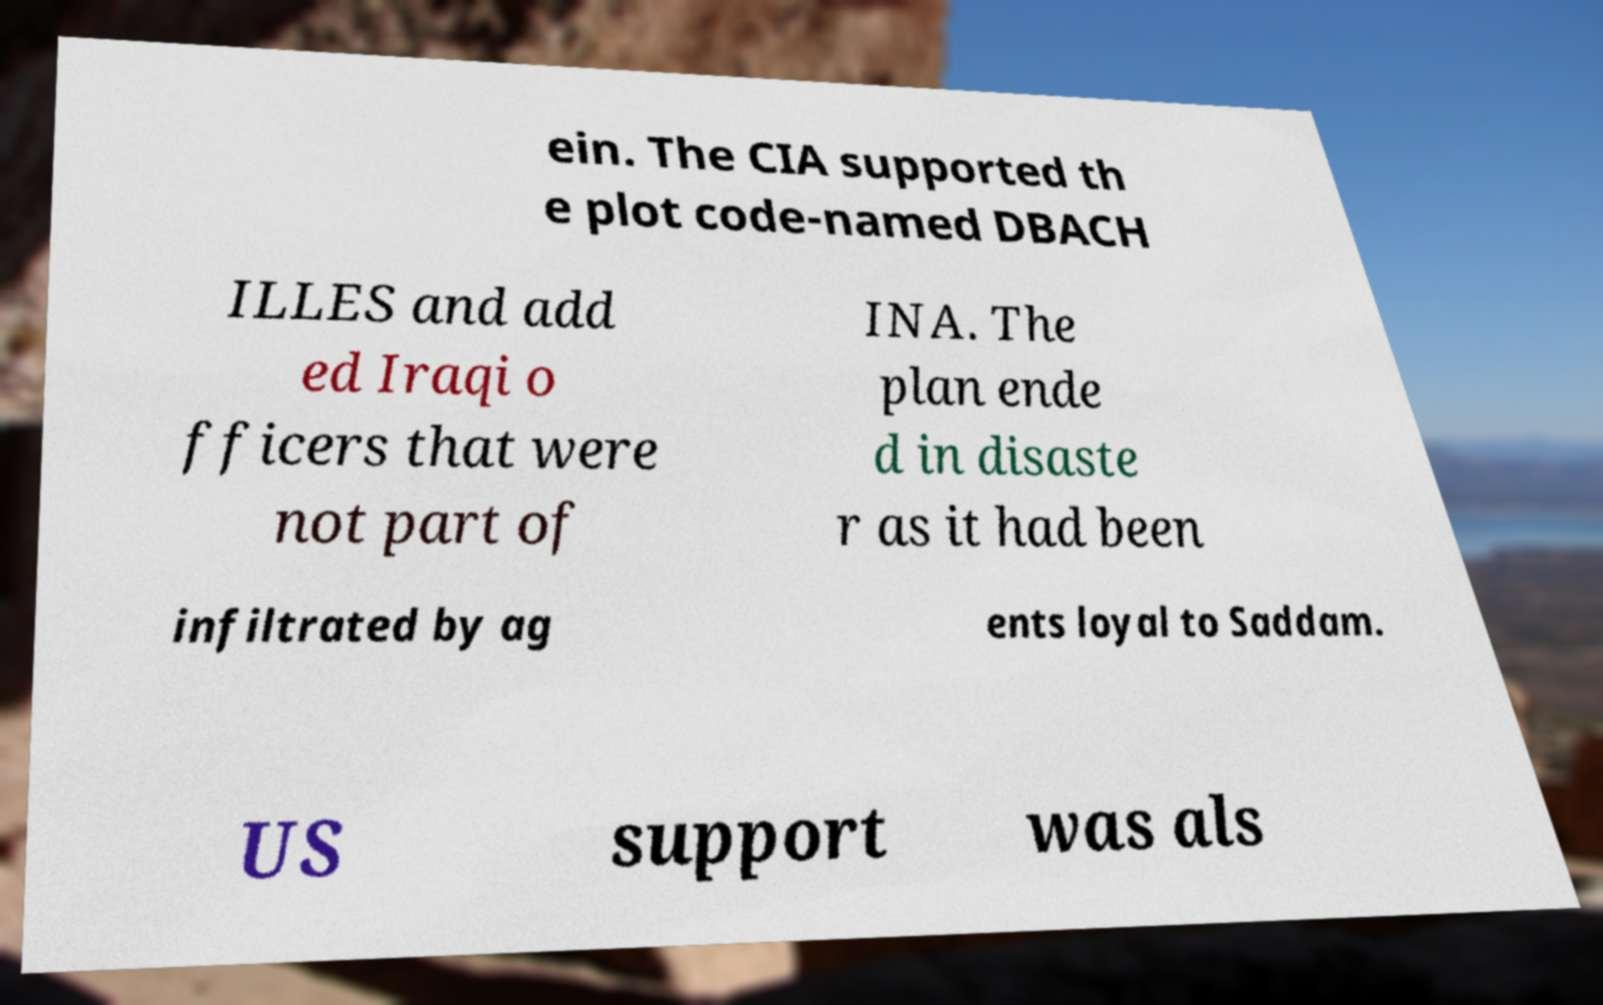For documentation purposes, I need the text within this image transcribed. Could you provide that? ein. The CIA supported th e plot code-named DBACH ILLES and add ed Iraqi o fficers that were not part of INA. The plan ende d in disaste r as it had been infiltrated by ag ents loyal to Saddam. US support was als 